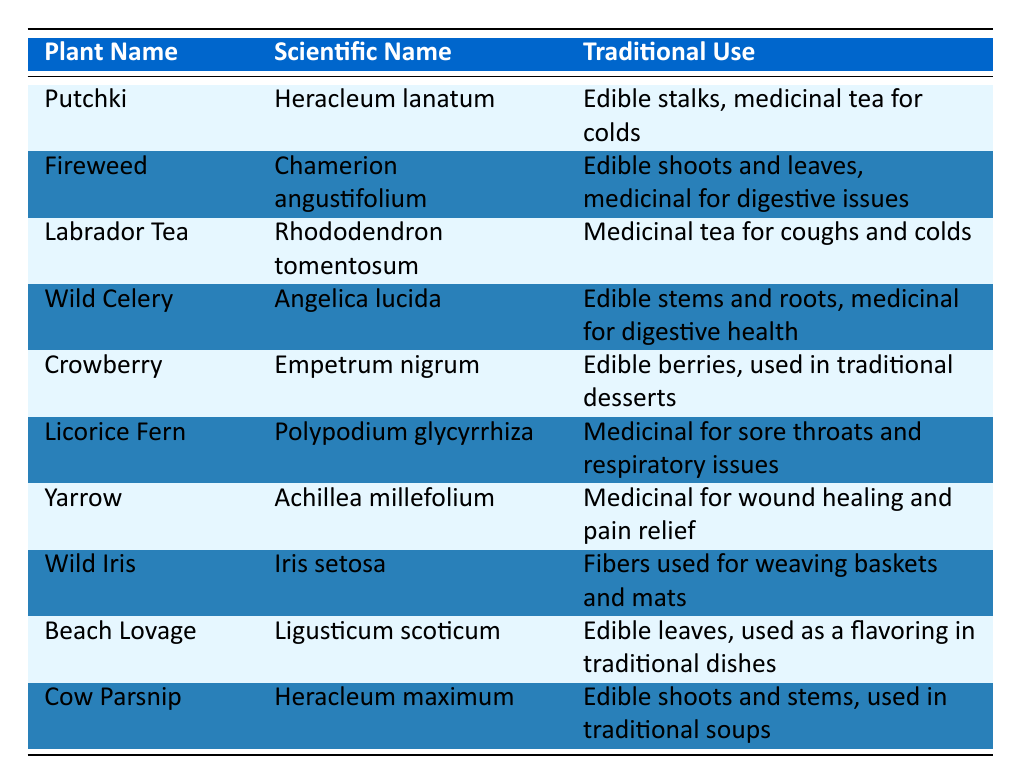What is the scientific name of Fireweed? The table lists Fireweed under the "Plant Name" column, and its corresponding scientific name is found in the second column. By looking at the row for Fireweed, we can see that its scientific name is Chamerion angustifolium.
Answer: Chamerion angustifolium Which plant is used for medicinal tea for coughs and colds? The third column of the table states the traditional uses of each plant. By scanning through this column, we find that Labrador Tea is specifically noted for being used as a medicinal tea for coughs and colds.
Answer: Labrador Tea How many plants listed are used for digestive health? To answer this, we need to count the entries in the third column that mention digestive health. The plants that relate to digestive health are: Fireweed and Wild Celery, which means there are 2 plants used for this purpose.
Answer: 2 Is Crowberry considered edible? The table indicates the uses for each plant. For Crowberry, it specifically states "Edible berries," indicating that Crowberry is indeed considered edible.
Answer: Yes Which plant has fibers used for weaving baskets and mats? Reviewing the third column of the table, we find that Wild Iris is noted for having fibers that can be used for weaving baskets and mats, making it the correct answer.
Answer: Wild Iris What is the traditional use of Licorice Fern? Looking in the third column for Licorice Fern, we see that it is stated as "Medicinal for sore throats and respiratory issues." Therefore, this provides the answer to its traditional use.
Answer: Medicinal for sore throats and respiratory issues Which two plants listed have edible parts? We need to identify plants from the table that specifically mention edibility in their traditional uses. The plants are: Putchki (edible stalks), Fireweed (edible shoots and leaves), Wild Celery (edible stems and roots), Crowberry (edible berries), Beach Lovage (edible leaves), and Cow Parsnip (edible shoots and stems). Counting these, we find that there are 6 plants that fit this description.
Answer: 6 What is the traditional use of Yarrow? By finding Yarrow in the table, particularly in the third column, we see it is described as "Medicinal for wound healing and pain relief," which gives us its traditional use.
Answer: Medicinal for wound healing and pain relief Which plant is used as a flavoring in traditional dishes? By scanning through the traditional uses in the third column, we can see that Beach Lovage is specifically noted as being used as a flavoring in traditional dishes.
Answer: Beach Lovage 